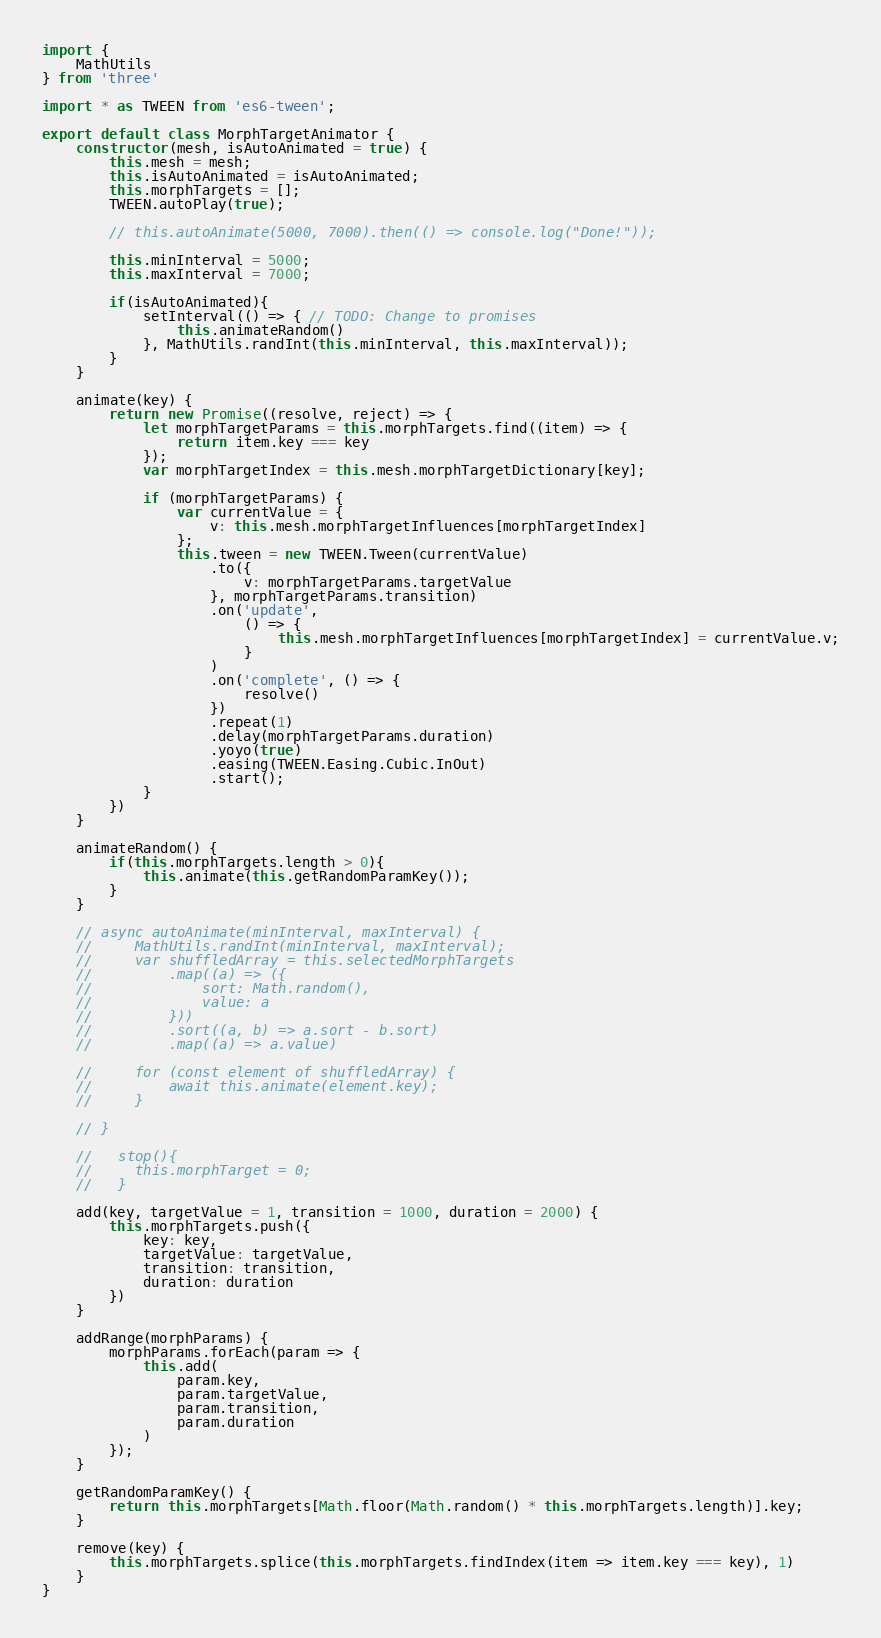Convert code to text. <code><loc_0><loc_0><loc_500><loc_500><_JavaScript_>import {
    MathUtils
} from 'three'

import * as TWEEN from 'es6-tween';

export default class MorphTargetAnimator {
    constructor(mesh, isAutoAnimated = true) {
        this.mesh = mesh;
        this.isAutoAnimated = isAutoAnimated;
        this.morphTargets = [];
        TWEEN.autoPlay(true);

        // this.autoAnimate(5000, 7000).then(() => console.log("Done!"));

        this.minInterval = 5000;
        this.maxInterval = 7000;

        if(isAutoAnimated){
            setInterval(() => { // TODO: Change to promises
                this.animateRandom()
            }, MathUtils.randInt(this.minInterval, this.maxInterval));
        }
    }

    animate(key) {
        return new Promise((resolve, reject) => {
            let morphTargetParams = this.morphTargets.find((item) => {
                return item.key === key
            });
            var morphTargetIndex = this.mesh.morphTargetDictionary[key];
            
            if (morphTargetParams) {
                var currentValue = {
                    v: this.mesh.morphTargetInfluences[morphTargetIndex]
                };
                this.tween = new TWEEN.Tween(currentValue)
                    .to({
                        v: morphTargetParams.targetValue
                    }, morphTargetParams.transition)
                    .on('update',
                        () => {
                            this.mesh.morphTargetInfluences[morphTargetIndex] = currentValue.v;
                        }
                    )
                    .on('complete', () => {
                        resolve()
                    })
                    .repeat(1)
                    .delay(morphTargetParams.duration)
                    .yoyo(true)
                    .easing(TWEEN.Easing.Cubic.InOut)
                    .start();
            }
        })
    }

    animateRandom() {
        if(this.morphTargets.length > 0){
            this.animate(this.getRandomParamKey());
        }
    }

    // async autoAnimate(minInterval, maxInterval) {   
    //     MathUtils.randInt(minInterval, maxInterval);
    //     var shuffledArray = this.selectedMorphTargets
    //         .map((a) => ({
    //             sort: Math.random(),
    //             value: a
    //         }))
    //         .sort((a, b) => a.sort - b.sort)
    //         .map((a) => a.value)

    //     for (const element of shuffledArray) {
    //         await this.animate(element.key);
    //     }

    // }

    //   stop(){
    //     this.morphTarget = 0;
    //   }

    add(key, targetValue = 1, transition = 1000, duration = 2000) {
        this.morphTargets.push({
            key: key,
            targetValue: targetValue,
            transition: transition,
            duration: duration
        })
    }

    addRange(morphParams) {
        morphParams.forEach(param => {
            this.add(
                param.key,
                param.targetValue,
                param.transition,
                param.duration
            )
        });
    }

    getRandomParamKey() {
        return this.morphTargets[Math.floor(Math.random() * this.morphTargets.length)].key;
    }

    remove(key) {
        this.morphTargets.splice(this.morphTargets.findIndex(item => item.key === key), 1)
    }
}</code> 